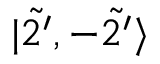Convert formula to latex. <formula><loc_0><loc_0><loc_500><loc_500>| \tilde { 2 ^ { \prime } } , - \tilde { 2 ^ { \prime } } \rangle</formula> 